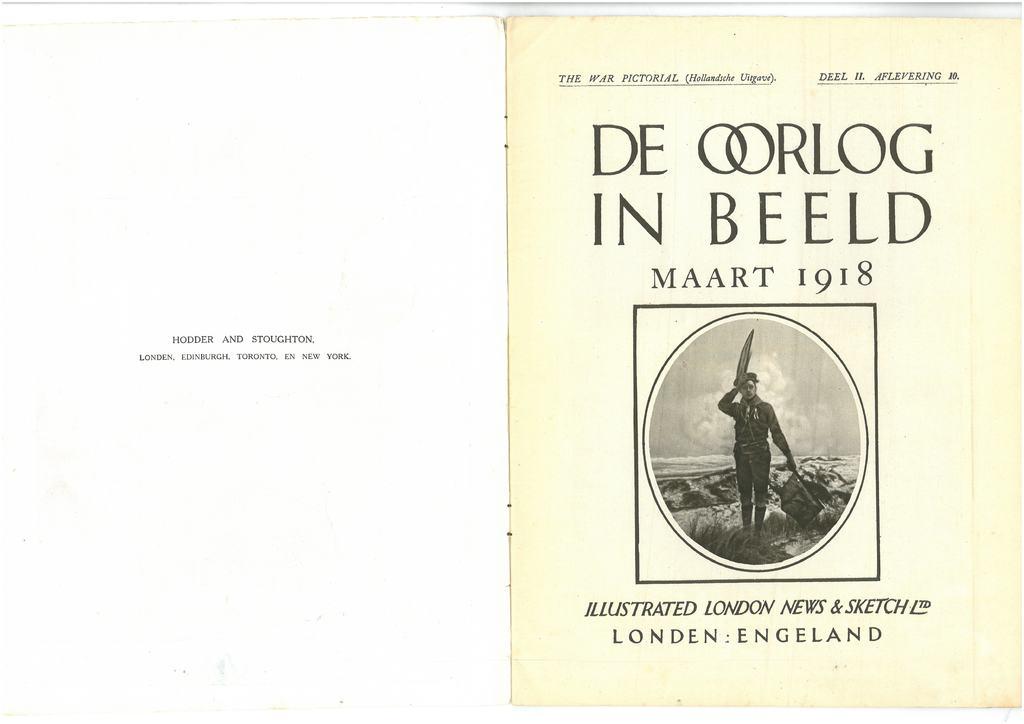What country is mentioned?
Offer a very short reply. Engeland. 